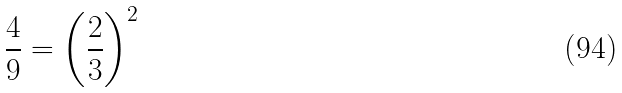<formula> <loc_0><loc_0><loc_500><loc_500>\frac { 4 } { 9 } = \left ( { \frac { 2 } { 3 } } \right ) ^ { 2 }</formula> 